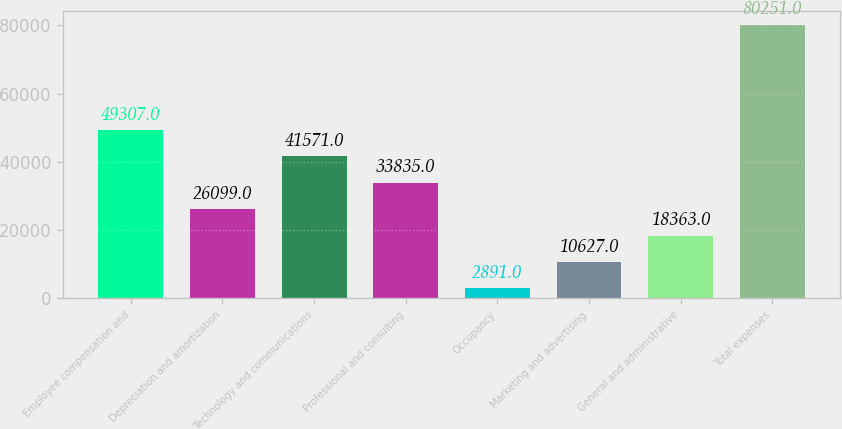Convert chart to OTSL. <chart><loc_0><loc_0><loc_500><loc_500><bar_chart><fcel>Employee compensation and<fcel>Depreciation and amortization<fcel>Technology and communications<fcel>Professional and consulting<fcel>Occupancy<fcel>Marketing and advertising<fcel>General and administrative<fcel>Total expenses<nl><fcel>49307<fcel>26099<fcel>41571<fcel>33835<fcel>2891<fcel>10627<fcel>18363<fcel>80251<nl></chart> 